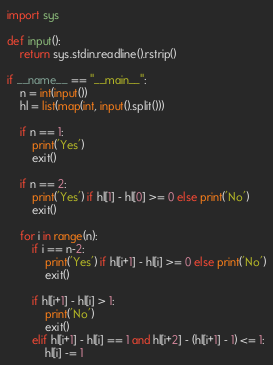<code> <loc_0><loc_0><loc_500><loc_500><_Python_>import sys

def input():
    return sys.stdin.readline().rstrip()

if __name__ == "__main__":
    n = int(input())
    hl = list(map(int, input().split()))

    if n == 1:
        print('Yes')
        exit()

    if n == 2:
        print('Yes') if hl[1] - hl[0] >= 0 else print('No')
        exit()

    for i in range(n):
        if i == n-2:
            print('Yes') if hl[i+1] - hl[i] >= 0 else print('No')
            exit()

        if hl[i+1] - hl[i] > 1:
            print('No')
            exit()
        elif hl[i+1] - hl[i] == 1 and hl[i+2] - (hl[i+1] - 1) <= 1:
            hl[i] -= 1
</code> 